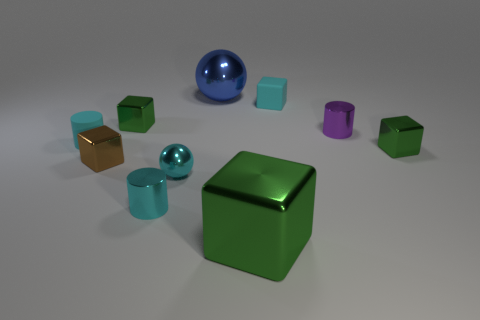The large shiny thing that is behind the cylinder in front of the small green shiny object that is to the right of the purple metal cylinder is what color? The large shiny object positioned behind the cylinder, which lies in front of the small green shiny object to the right of the purple metal cylinder, exhibits a vibrant blue color. 